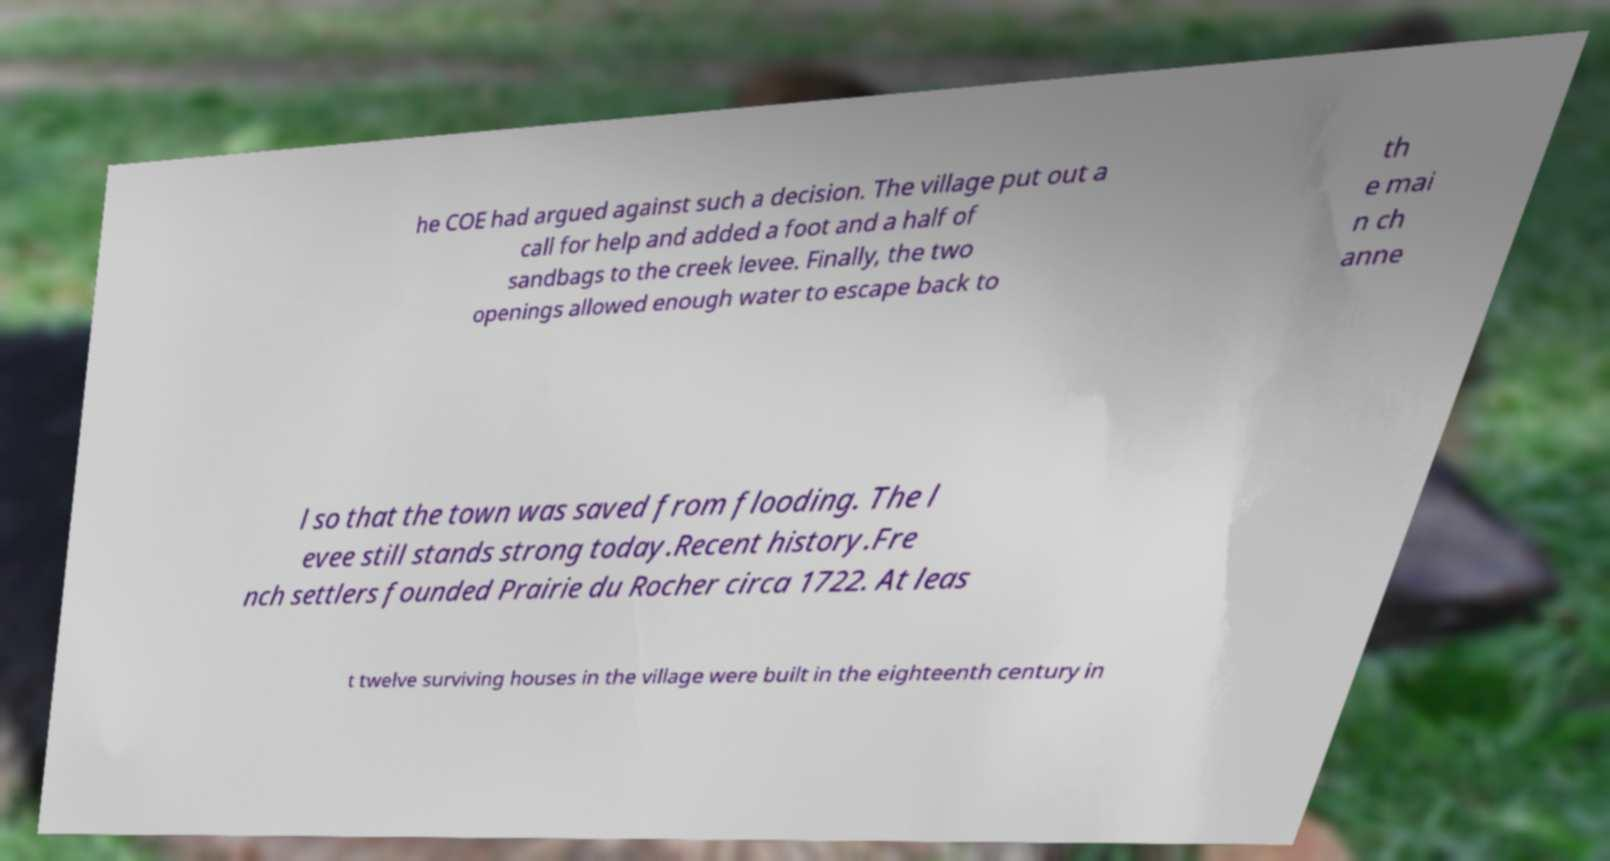Can you read and provide the text displayed in the image?This photo seems to have some interesting text. Can you extract and type it out for me? he COE had argued against such a decision. The village put out a call for help and added a foot and a half of sandbags to the creek levee. Finally, the two openings allowed enough water to escape back to th e mai n ch anne l so that the town was saved from flooding. The l evee still stands strong today.Recent history.Fre nch settlers founded Prairie du Rocher circa 1722. At leas t twelve surviving houses in the village were built in the eighteenth century in 